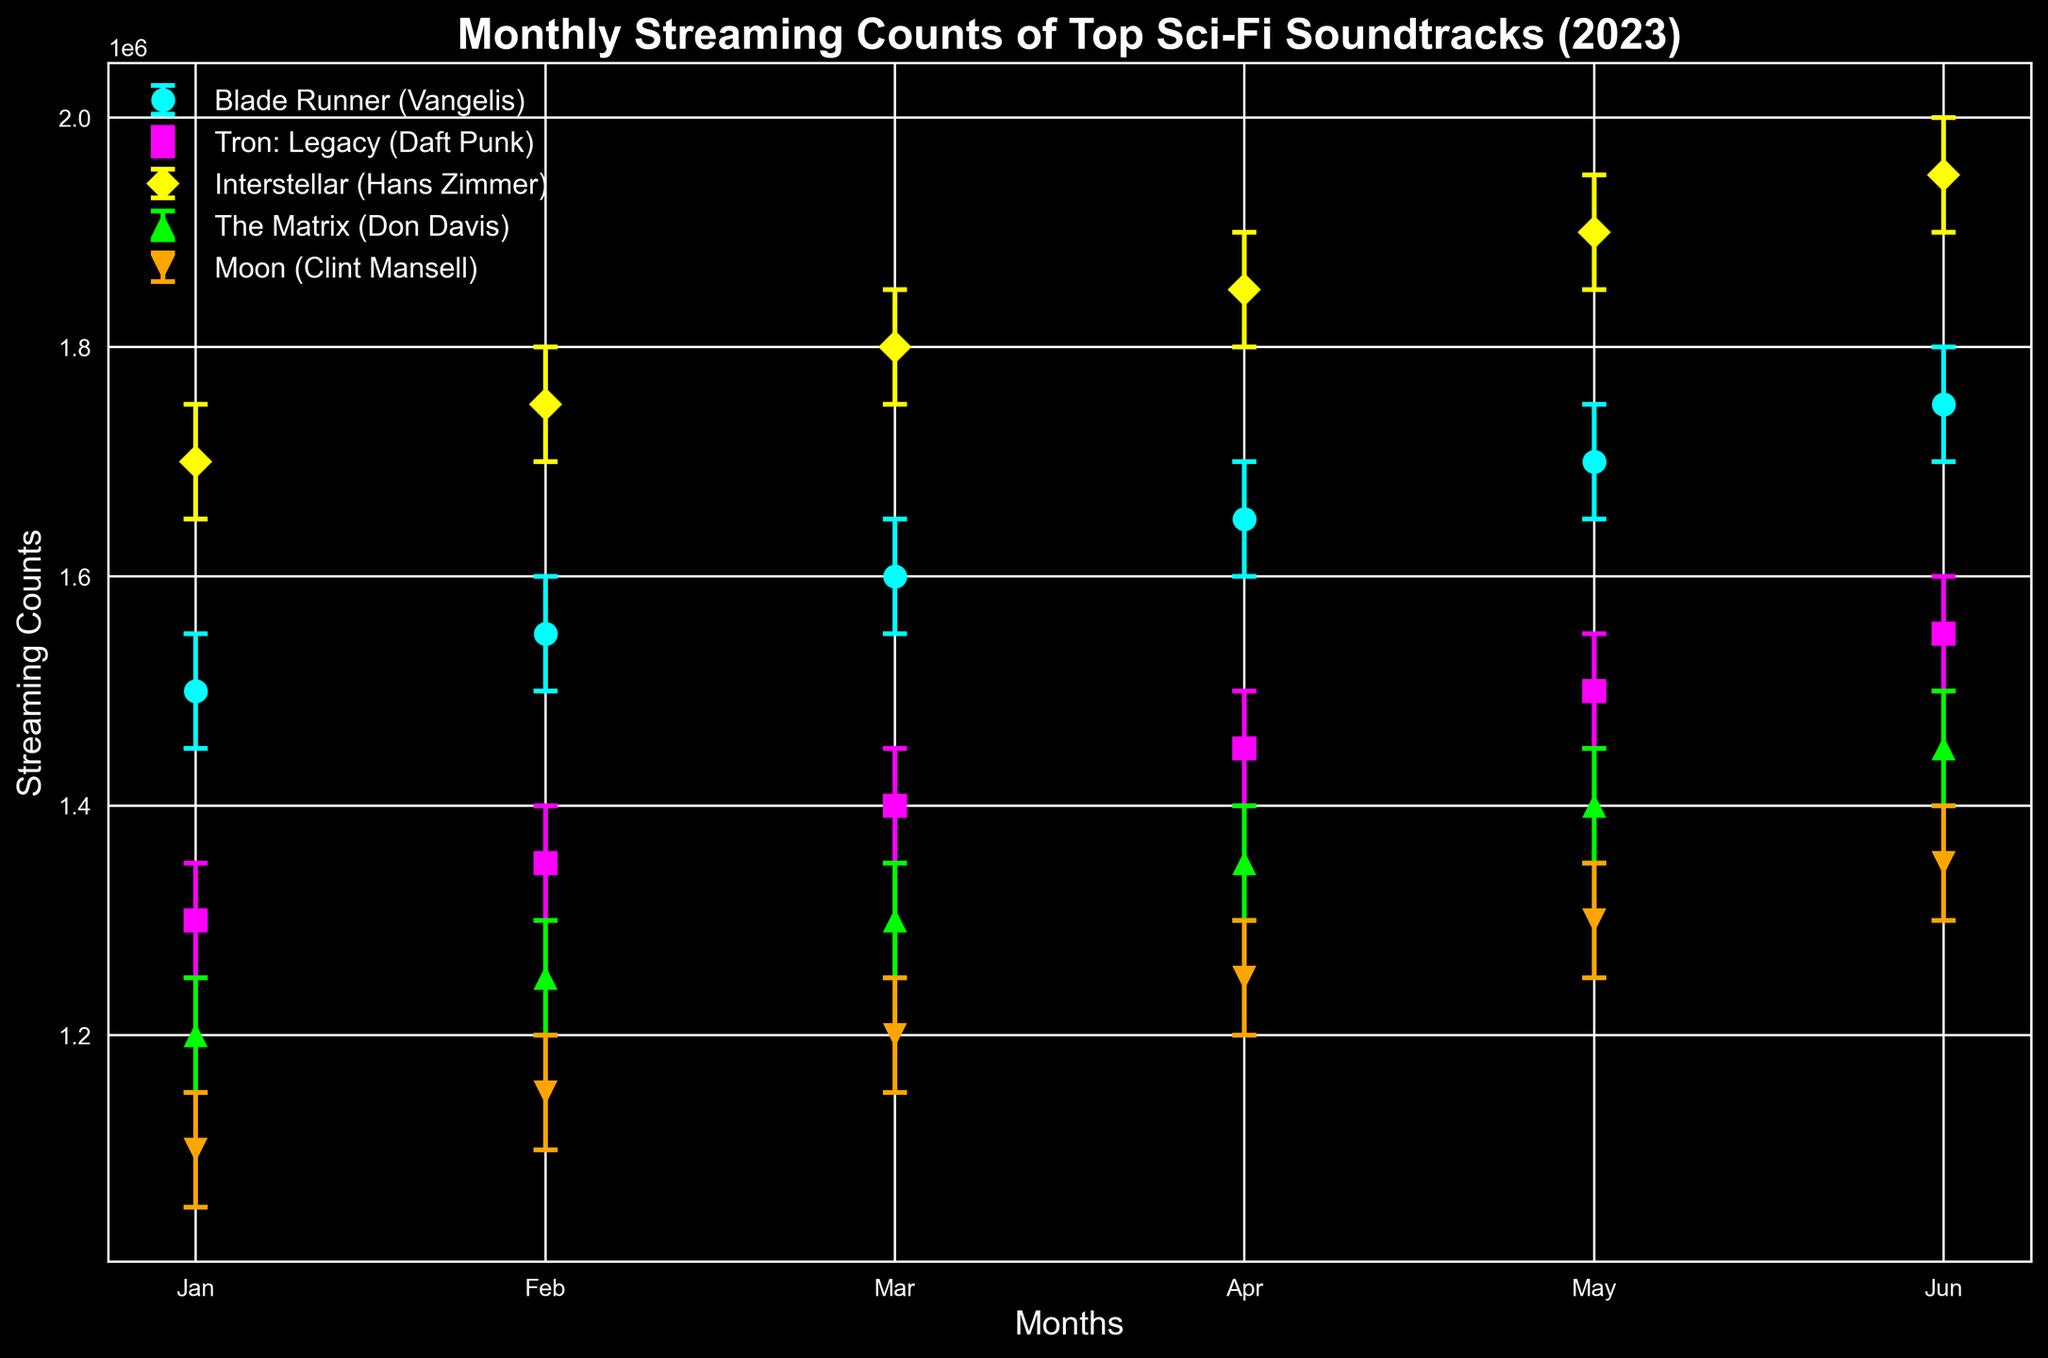What is the average monthly streaming count for "Interstellar (Hans Zimmer)" across the first six months of 2023? To find the average, add the monthly streaming counts for "Interstellar (Hans Zimmer)": 1700000 + 1750000 + 1800000 + 1850000 + 1900000 + 1950000 = 10950000. Then, divide by the six months: 10950000 / 6 = 1825000.
Answer: 1825000 Which soundtrack had the highest streaming count in June 2023? Look at the streaming counts for June 2023. "Interstellar (Hans Zimmer)" has the highest count at 1950000.
Answer: Interstellar (Hans Zimmer) How much did the streaming count for "Tron: Legacy (Daft Punk)" increase from January to June 2023? First, find the streaming counts for January and June: 1300000 and 1550000 respectively. The increase is 1550000 - 1300000 = 250000.
Answer: 250000 Which month saw the biggest jump in streaming counts for "Blade Runner (Vangelis)" compared to the previous month? Calculate monthly increases: Jan to Feb (1550000 - 1500000 = 50000), Feb to Mar (1600000 - 1550000 = 50000), Mar to Apr (1650000 - 1600000 = 50000), Apr to May (1700000 - 1650000 = 50000), May to Jun (1750000 - 1700000 = 50000). All increases are equal at 50000, so there is no single biggest jump.
Answer: No single biggest jump Which soundtrack consistently increased its streaming counts every month from January to June 2023? Check each soundtrack's streaming counts month by month: "Blade Runner (Vangelis)", "Tron: Legacy (Daft Punk)", "Interstellar (Hans Zimmer)", "The Matrix (Don Davis)", and "Moon (Clint Mansell)". Only "Interstellar (Hans Zimmer)" increased its streaming counts every month.
Answer: Interstellar (Hans Zimmer) What is the range of the confidence interval for "The Matrix (Don Davis)" in April 2023? The CI range is calculated as CI_Upper - CI_Lower. For April, it's 1400000 - 1300000 = 100000.
Answer: 100000 Which soundtrack had the smallest confidence interval range in January 2023? Calculate the CI ranges for January: "Blade Runner (Vangelis)" (1550000 - 1450000 = 100000), "Tron: Legacy (Daft Punk)" (1350000 - 1250000 = 100000), "Interstellar (Hans Zimmer)" (1750000 - 1650000 = 100000), "The Matrix (Don Davis)" (1250000 - 1150000 = 100000), "Moon (Clint Mansell)" (1150000 - 1050000 = 100000). All ranges are equal at 100000, so no single smallest range.
Answer: No single smallest range What was the total combined streaming count for all soundtracks in May 2023? Add the streaming counts for May: 1700000 (Blade Runner) + 1500000 (Tron: Legacy) + 1900000 (Interstellar) + 1400000 (The Matrix) + 1300000 (Moon) = 7800000.
Answer: 7800000 